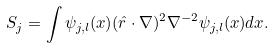<formula> <loc_0><loc_0><loc_500><loc_500>S _ { j } = \int \psi _ { j , l } ( { x } ) ( \hat { r } \cdot \nabla ) ^ { 2 } \nabla ^ { - 2 } \psi _ { j , l } ( { x } ) d { x } .</formula> 